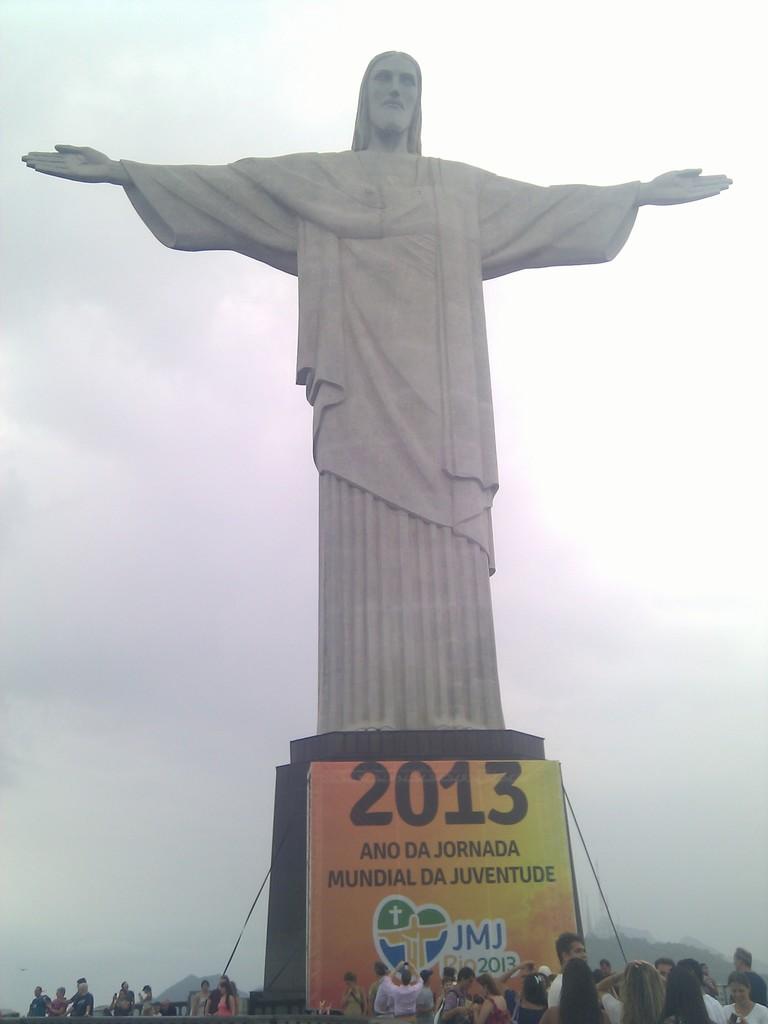What are the 3 letters beside the heart?
Make the answer very short. Jmj. 